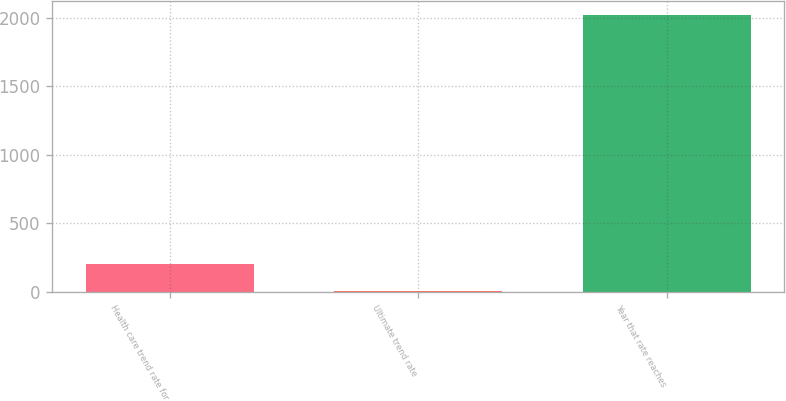Convert chart to OTSL. <chart><loc_0><loc_0><loc_500><loc_500><bar_chart><fcel>Health care trend rate for<fcel>Ultimate trend rate<fcel>Year that rate reaches<nl><fcel>206.5<fcel>5<fcel>2020<nl></chart> 